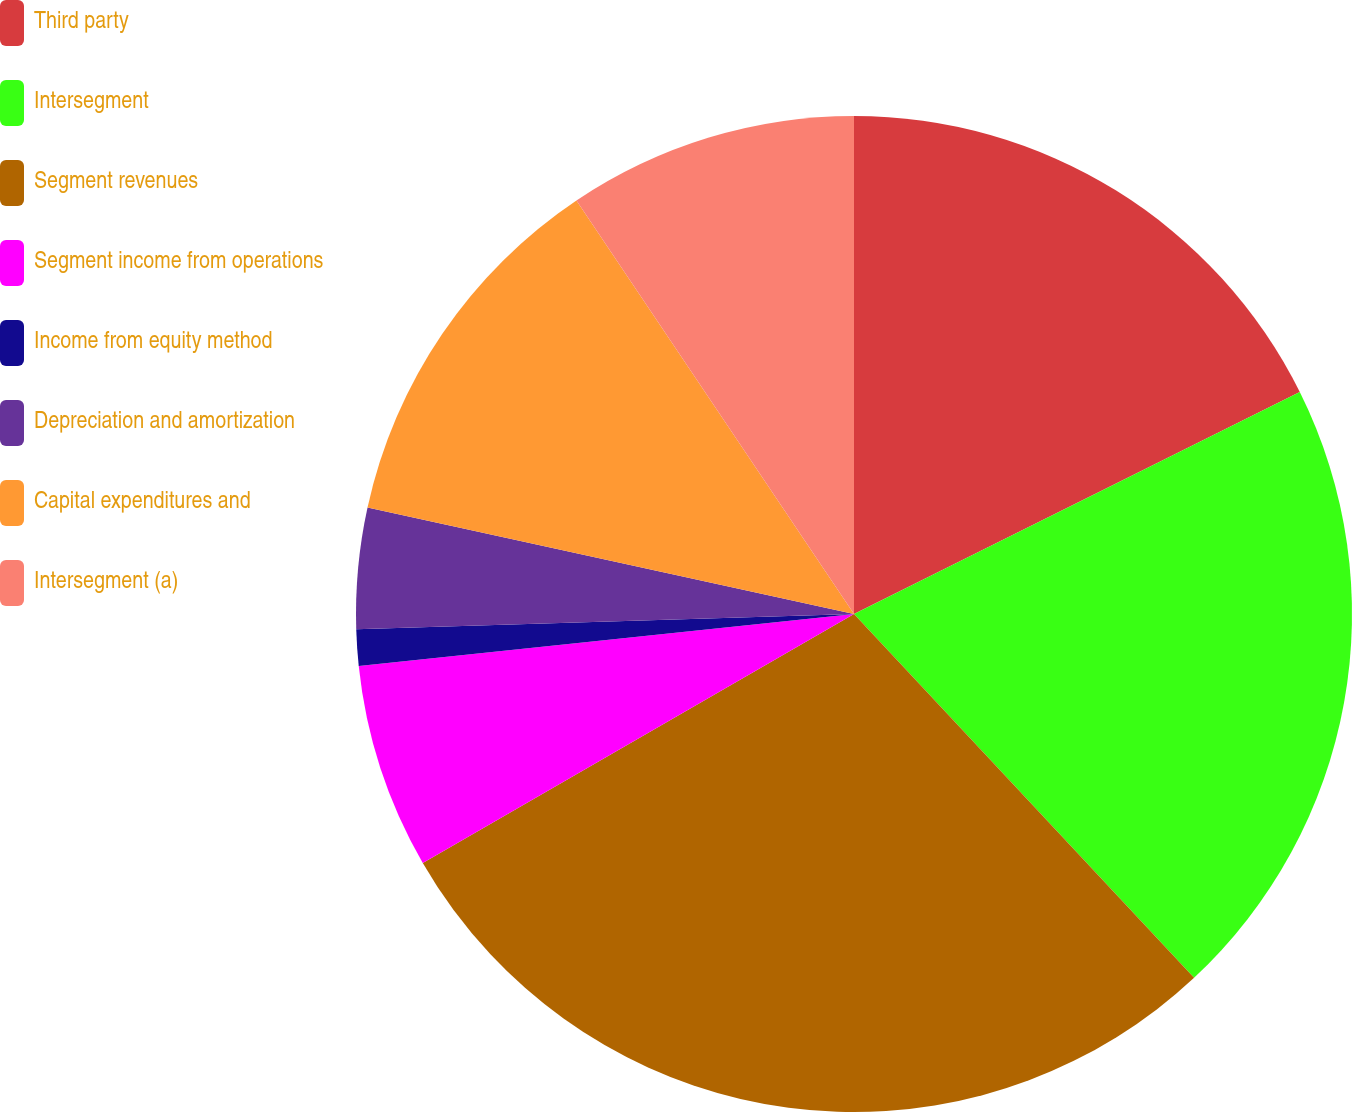Convert chart to OTSL. <chart><loc_0><loc_0><loc_500><loc_500><pie_chart><fcel>Third party<fcel>Intersegment<fcel>Segment revenues<fcel>Segment income from operations<fcel>Income from equity method<fcel>Depreciation and amortization<fcel>Capital expenditures and<fcel>Intersegment (a)<nl><fcel>17.65%<fcel>20.39%<fcel>28.63%<fcel>6.67%<fcel>1.18%<fcel>3.92%<fcel>12.16%<fcel>9.41%<nl></chart> 